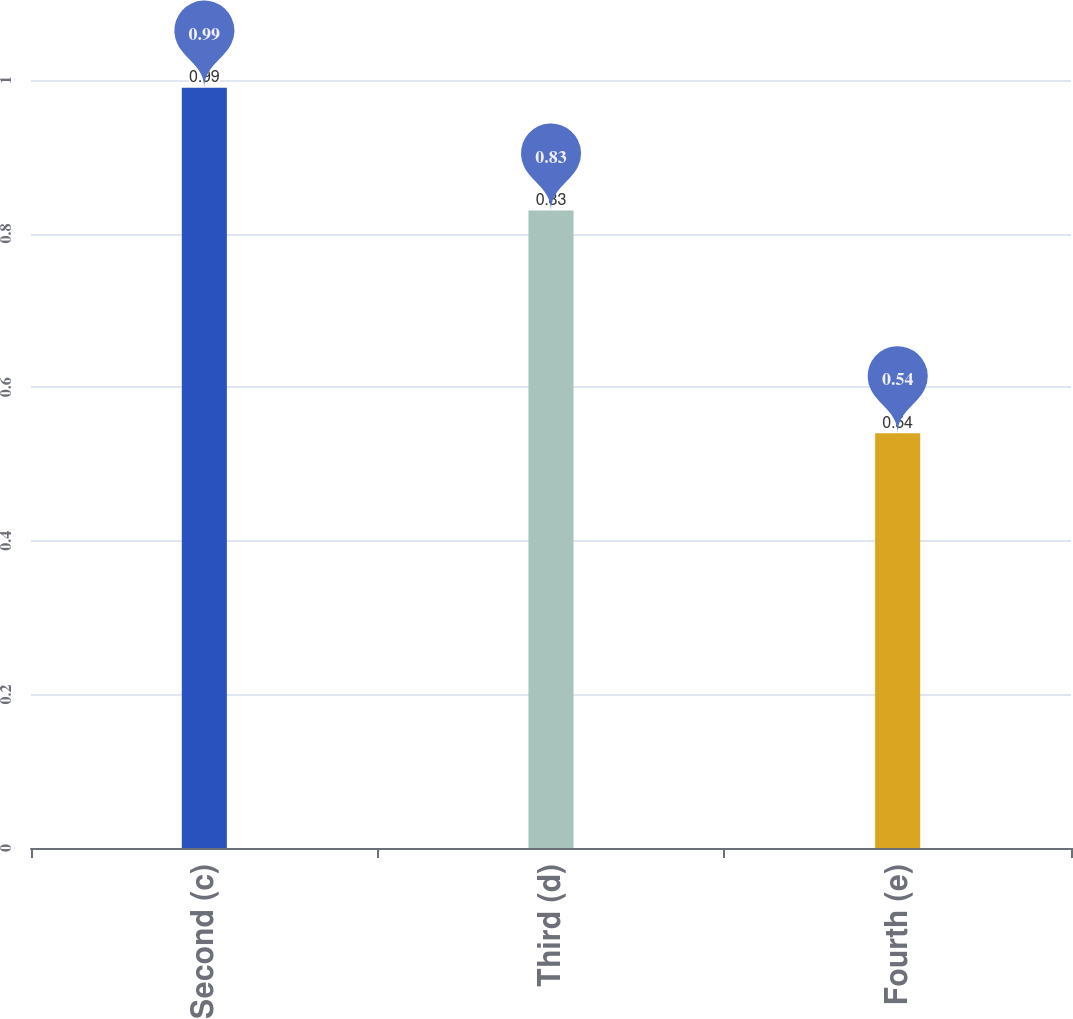Convert chart to OTSL. <chart><loc_0><loc_0><loc_500><loc_500><bar_chart><fcel>Second (c)<fcel>Third (d)<fcel>Fourth (e)<nl><fcel>0.99<fcel>0.83<fcel>0.54<nl></chart> 